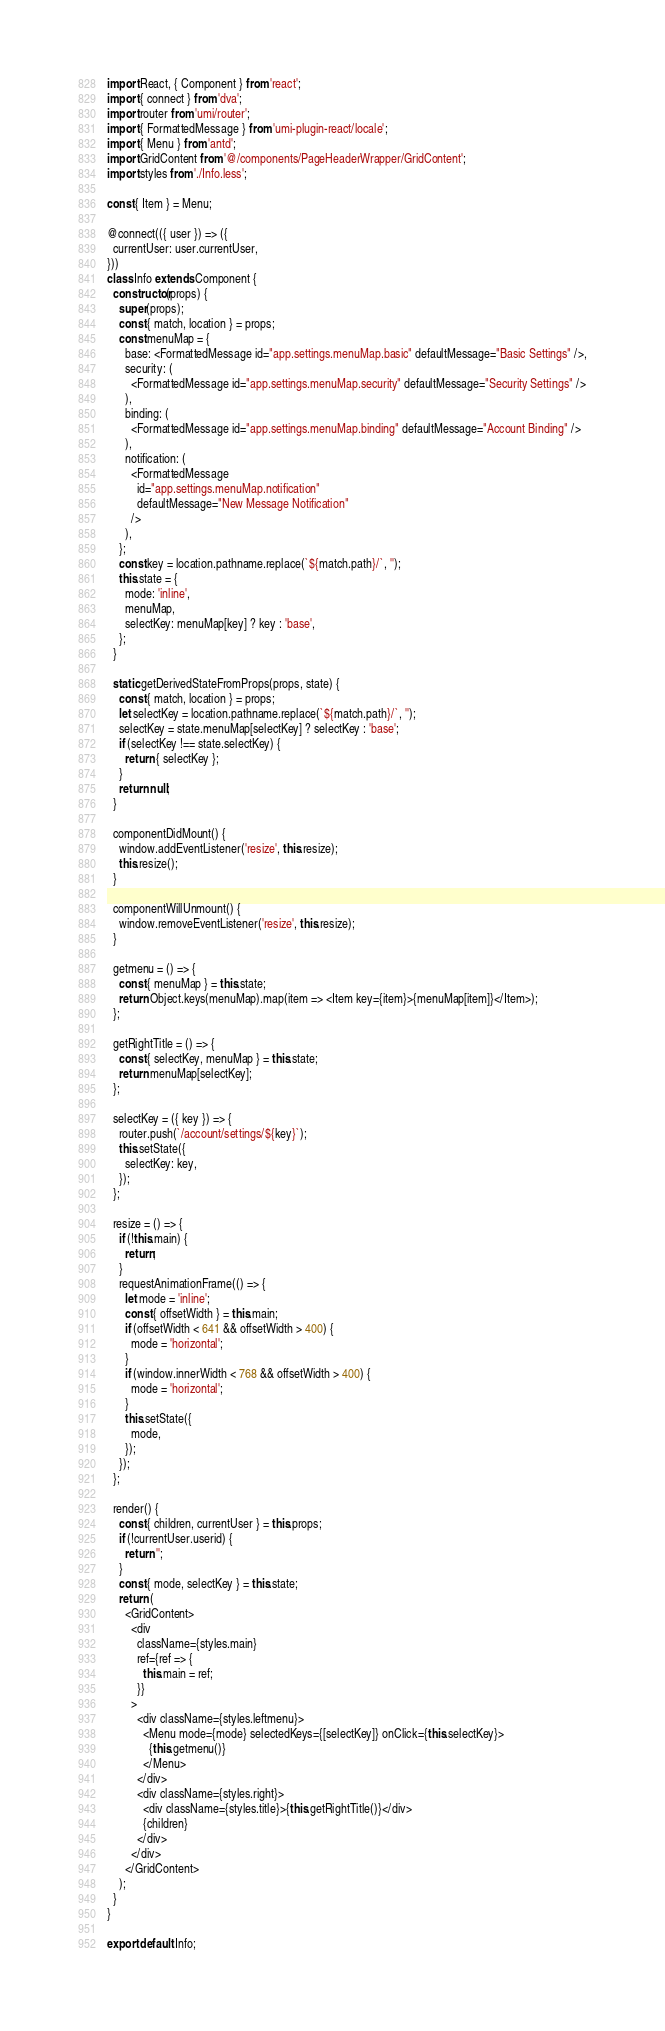Convert code to text. <code><loc_0><loc_0><loc_500><loc_500><_JavaScript_>import React, { Component } from 'react';
import { connect } from 'dva';
import router from 'umi/router';
import { FormattedMessage } from 'umi-plugin-react/locale';
import { Menu } from 'antd';
import GridContent from '@/components/PageHeaderWrapper/GridContent';
import styles from './Info.less';

const { Item } = Menu;

@connect(({ user }) => ({
  currentUser: user.currentUser,
}))
class Info extends Component {
  constructor(props) {
    super(props);
    const { match, location } = props;
    const menuMap = {
      base: <FormattedMessage id="app.settings.menuMap.basic" defaultMessage="Basic Settings" />,
      security: (
        <FormattedMessage id="app.settings.menuMap.security" defaultMessage="Security Settings" />
      ),
      binding: (
        <FormattedMessage id="app.settings.menuMap.binding" defaultMessage="Account Binding" />
      ),
      notification: (
        <FormattedMessage
          id="app.settings.menuMap.notification"
          defaultMessage="New Message Notification"
        />
      ),
    };
    const key = location.pathname.replace(`${match.path}/`, '');
    this.state = {
      mode: 'inline',
      menuMap,
      selectKey: menuMap[key] ? key : 'base',
    };
  }

  static getDerivedStateFromProps(props, state) {
    const { match, location } = props;
    let selectKey = location.pathname.replace(`${match.path}/`, '');
    selectKey = state.menuMap[selectKey] ? selectKey : 'base';
    if (selectKey !== state.selectKey) {
      return { selectKey };
    }
    return null;
  }

  componentDidMount() {
    window.addEventListener('resize', this.resize);
    this.resize();
  }

  componentWillUnmount() {
    window.removeEventListener('resize', this.resize);
  }

  getmenu = () => {
    const { menuMap } = this.state;
    return Object.keys(menuMap).map(item => <Item key={item}>{menuMap[item]}</Item>);
  };

  getRightTitle = () => {
    const { selectKey, menuMap } = this.state;
    return menuMap[selectKey];
  };

  selectKey = ({ key }) => {
    router.push(`/account/settings/${key}`);
    this.setState({
      selectKey: key,
    });
  };

  resize = () => {
    if (!this.main) {
      return;
    }
    requestAnimationFrame(() => {
      let mode = 'inline';
      const { offsetWidth } = this.main;
      if (offsetWidth < 641 && offsetWidth > 400) {
        mode = 'horizontal';
      }
      if (window.innerWidth < 768 && offsetWidth > 400) {
        mode = 'horizontal';
      }
      this.setState({
        mode,
      });
    });
  };

  render() {
    const { children, currentUser } = this.props;
    if (!currentUser.userid) {
      return '';
    }
    const { mode, selectKey } = this.state;
    return (
      <GridContent>
        <div
          className={styles.main}
          ref={ref => {
            this.main = ref;
          }}
        >
          <div className={styles.leftmenu}>
            <Menu mode={mode} selectedKeys={[selectKey]} onClick={this.selectKey}>
              {this.getmenu()}
            </Menu>
          </div>
          <div className={styles.right}>
            <div className={styles.title}>{this.getRightTitle()}</div>
            {children}
          </div>
        </div>
      </GridContent>
    );
  }
}

export default Info;
</code> 